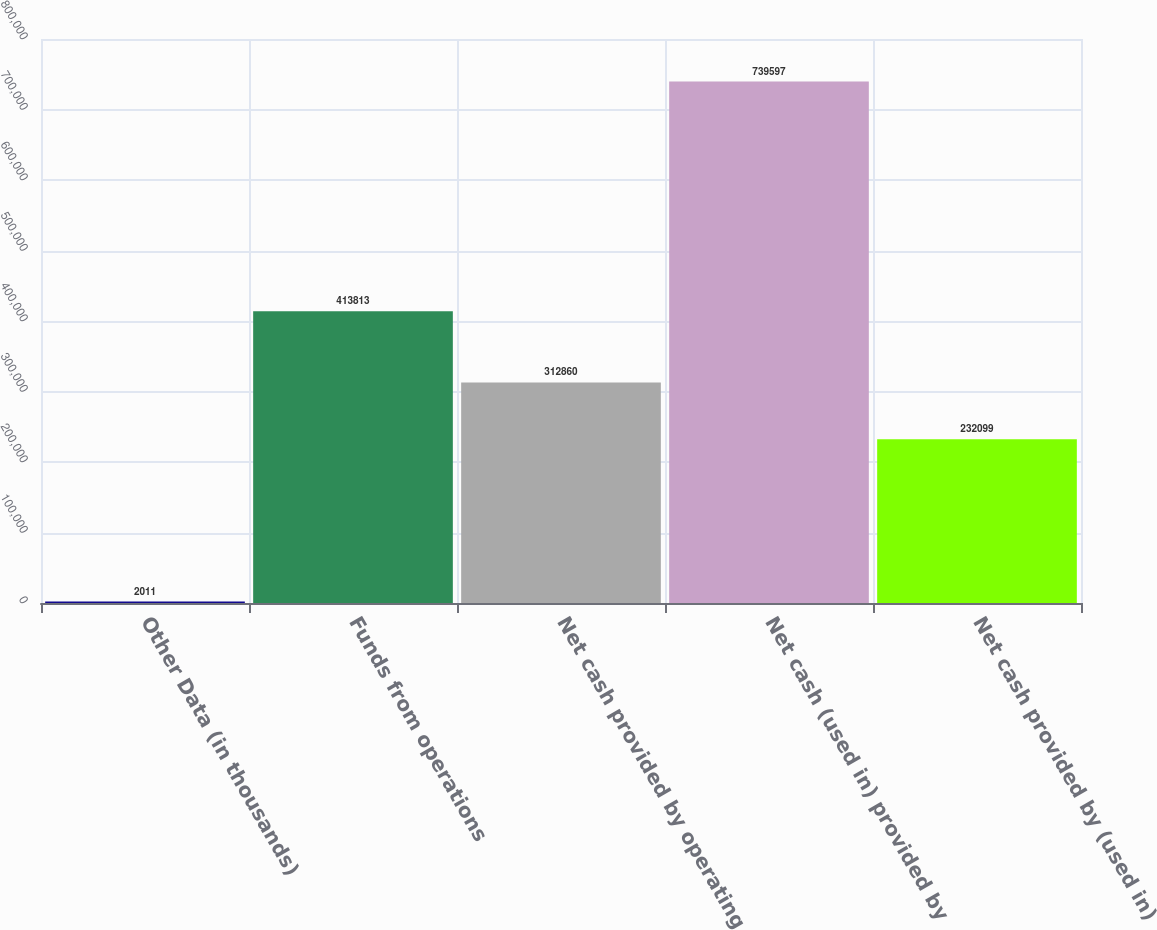Convert chart. <chart><loc_0><loc_0><loc_500><loc_500><bar_chart><fcel>Other Data (in thousands)<fcel>Funds from operations<fcel>Net cash provided by operating<fcel>Net cash (used in) provided by<fcel>Net cash provided by (used in)<nl><fcel>2011<fcel>413813<fcel>312860<fcel>739597<fcel>232099<nl></chart> 